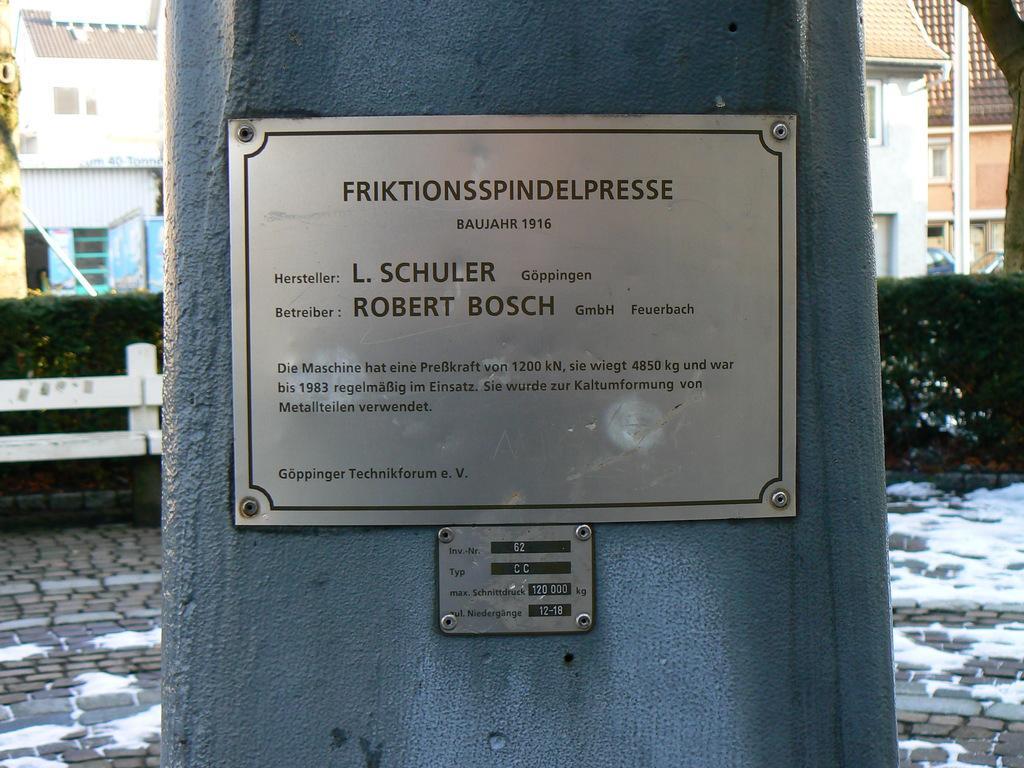How would you summarize this image in a sentence or two? There is a pillar with a name plate. In the background there is fencing, bushes, buildings with windows. On the ground there are bricks and snow. 